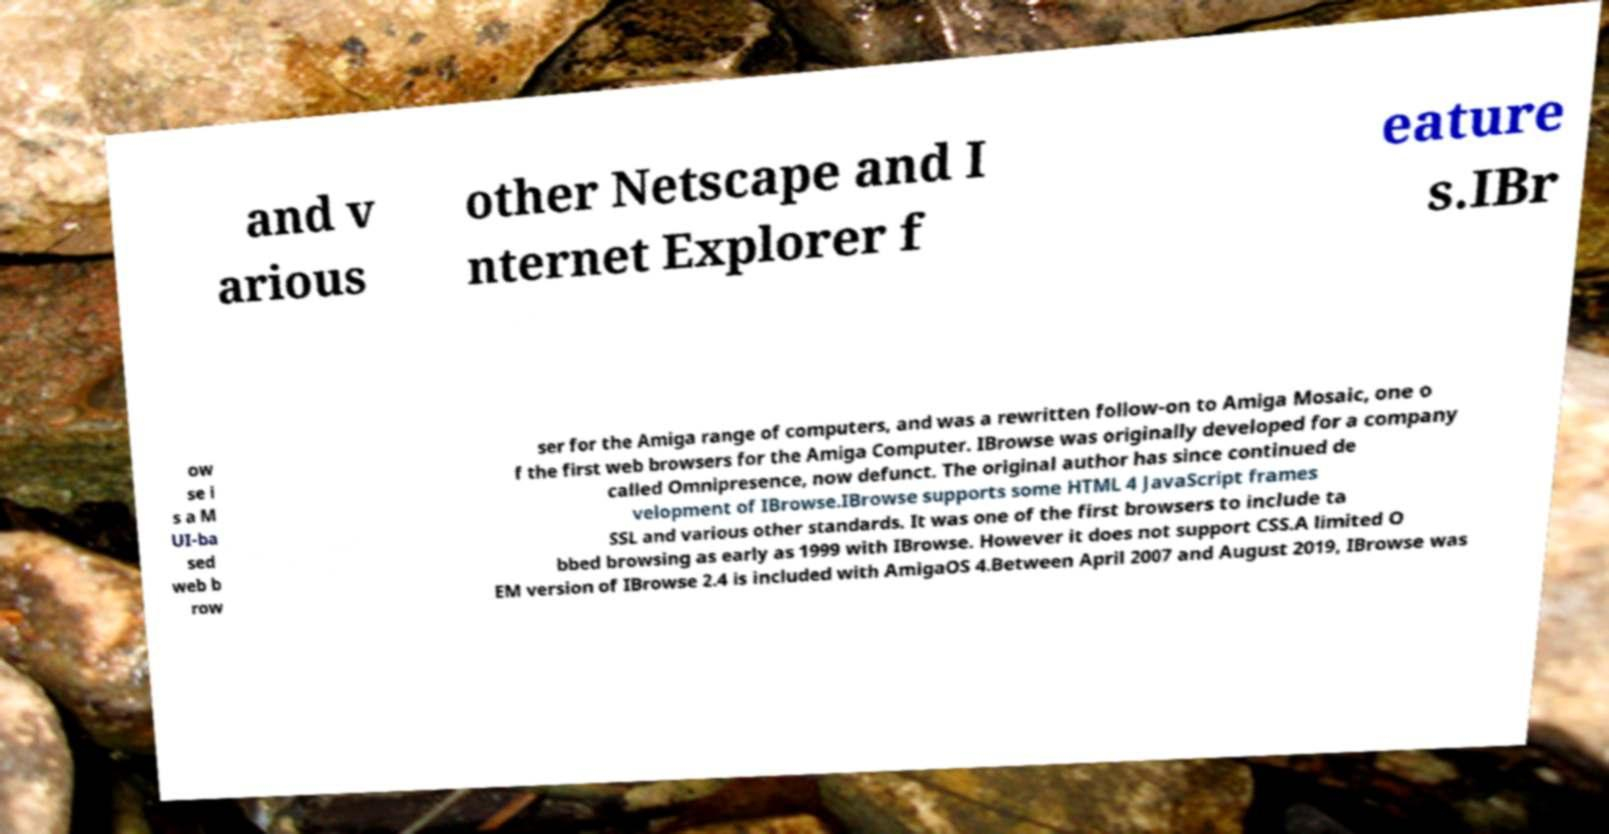Could you assist in decoding the text presented in this image and type it out clearly? and v arious other Netscape and I nternet Explorer f eature s.IBr ow se i s a M UI-ba sed web b row ser for the Amiga range of computers, and was a rewritten follow-on to Amiga Mosaic, one o f the first web browsers for the Amiga Computer. IBrowse was originally developed for a company called Omnipresence, now defunct. The original author has since continued de velopment of IBrowse.IBrowse supports some HTML 4 JavaScript frames SSL and various other standards. It was one of the first browsers to include ta bbed browsing as early as 1999 with IBrowse. However it does not support CSS.A limited O EM version of IBrowse 2.4 is included with AmigaOS 4.Between April 2007 and August 2019, IBrowse was 